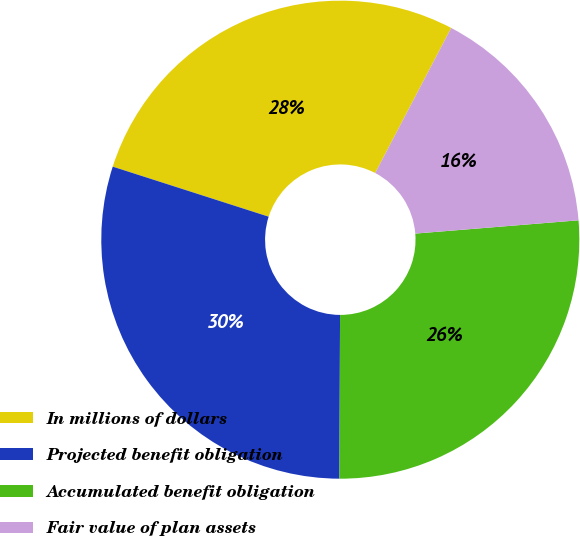Convert chart to OTSL. <chart><loc_0><loc_0><loc_500><loc_500><pie_chart><fcel>In millions of dollars<fcel>Projected benefit obligation<fcel>Accumulated benefit obligation<fcel>Fair value of plan assets<nl><fcel>27.74%<fcel>29.89%<fcel>26.35%<fcel>16.03%<nl></chart> 